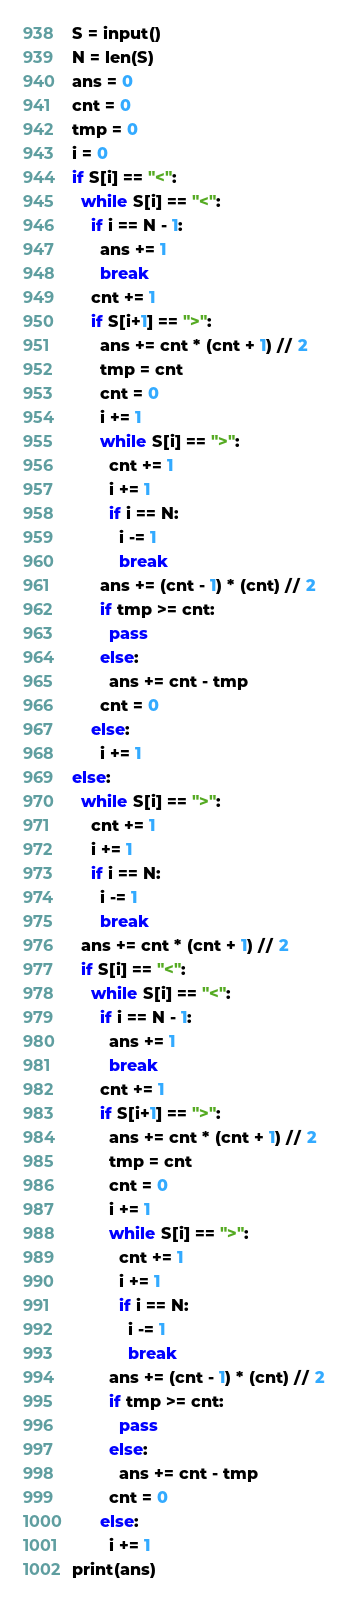<code> <loc_0><loc_0><loc_500><loc_500><_Python_>S = input()
N = len(S)
ans = 0
cnt = 0
tmp = 0
i = 0
if S[i] == "<":
  while S[i] == "<":
    if i == N - 1:
      ans += 1
      break
    cnt += 1
    if S[i+1] == ">":
      ans += cnt * (cnt + 1) // 2
      tmp = cnt
      cnt = 0
      i += 1
      while S[i] == ">":
        cnt += 1
        i += 1
        if i == N:
          i -= 1
          break
      ans += (cnt - 1) * (cnt) // 2
      if tmp >= cnt:
        pass
      else:
        ans += cnt - tmp
      cnt = 0
    else:
      i += 1
else:
  while S[i] == ">":
    cnt += 1
    i += 1
    if i == N:
      i -= 1
      break
  ans += cnt * (cnt + 1) // 2
  if S[i] == "<":
    while S[i] == "<":
      if i == N - 1:
        ans += 1
        break
      cnt += 1
      if S[i+1] == ">":
        ans += cnt * (cnt + 1) // 2
        tmp = cnt
        cnt = 0
        i += 1
        while S[i] == ">":
          cnt += 1
          i += 1
          if i == N:
            i -= 1
            break
        ans += (cnt - 1) * (cnt) // 2
        if tmp >= cnt:
          pass
        else:
          ans += cnt - tmp
        cnt = 0
      else:
        i += 1
print(ans)</code> 